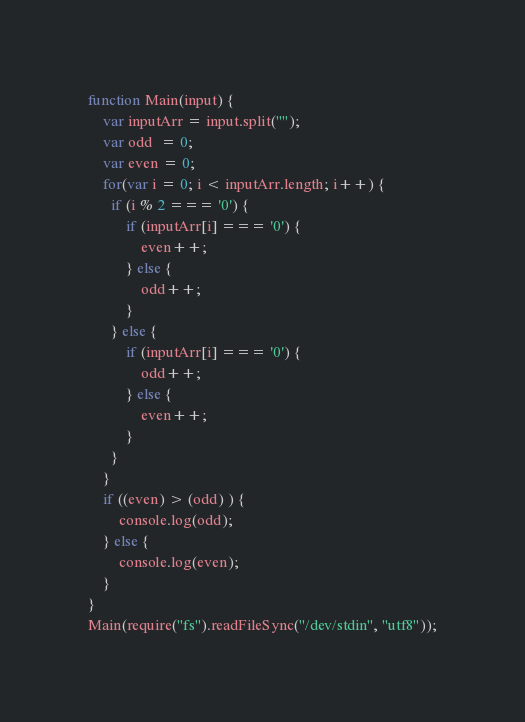<code> <loc_0><loc_0><loc_500><loc_500><_JavaScript_>function Main(input) {
	var inputArr = input.split("");
    var odd  = 0;
    var even = 0;
	for(var i = 0; i < inputArr.length; i++) {
      if (i % 2 === '0') {
          if (inputArr[i] === '0') {
              even++;
          } else {
              odd++;
          }
      } else {
          if (inputArr[i] === '0') {
              odd++;
          } else {
              even++;
          }
      }
	}
    if ((even) > (odd) ) {
    	console.log(odd);
    } else {
      	console.log(even);
    }
}
Main(require("fs").readFileSync("/dev/stdin", "utf8"));</code> 